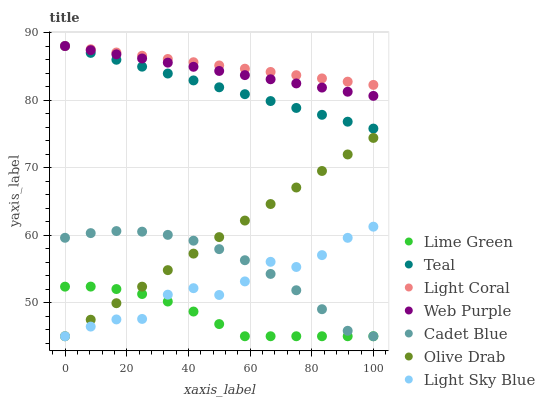Does Lime Green have the minimum area under the curve?
Answer yes or no. Yes. Does Light Coral have the maximum area under the curve?
Answer yes or no. Yes. Does Web Purple have the minimum area under the curve?
Answer yes or no. No. Does Web Purple have the maximum area under the curve?
Answer yes or no. No. Is Olive Drab the smoothest?
Answer yes or no. Yes. Is Light Sky Blue the roughest?
Answer yes or no. Yes. Is Light Coral the smoothest?
Answer yes or no. No. Is Light Coral the roughest?
Answer yes or no. No. Does Cadet Blue have the lowest value?
Answer yes or no. Yes. Does Web Purple have the lowest value?
Answer yes or no. No. Does Teal have the highest value?
Answer yes or no. Yes. Does Light Sky Blue have the highest value?
Answer yes or no. No. Is Cadet Blue less than Web Purple?
Answer yes or no. Yes. Is Teal greater than Cadet Blue?
Answer yes or no. Yes. Does Cadet Blue intersect Light Sky Blue?
Answer yes or no. Yes. Is Cadet Blue less than Light Sky Blue?
Answer yes or no. No. Is Cadet Blue greater than Light Sky Blue?
Answer yes or no. No. Does Cadet Blue intersect Web Purple?
Answer yes or no. No. 